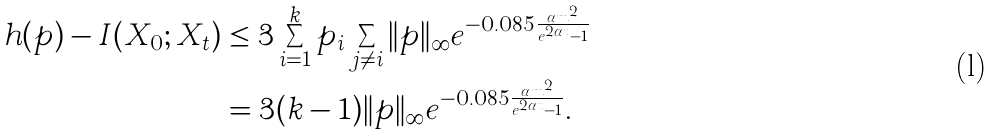<formula> <loc_0><loc_0><loc_500><loc_500>h ( p ) - I ( X _ { 0 } ; X _ { t } ) & \leq 3 \sum _ { i = 1 } ^ { k } p _ { i } \sum _ { j \neq i } \| p \| _ { \infty } e ^ { - 0 . 0 8 5 \frac { \alpha m ^ { 2 } } { e ^ { 2 \alpha t } - 1 } } \\ & = 3 ( k - 1 ) \| p \| _ { \infty } e ^ { - 0 . 0 8 5 \frac { \alpha m ^ { 2 } } { e ^ { 2 \alpha t } - 1 } } .</formula> 